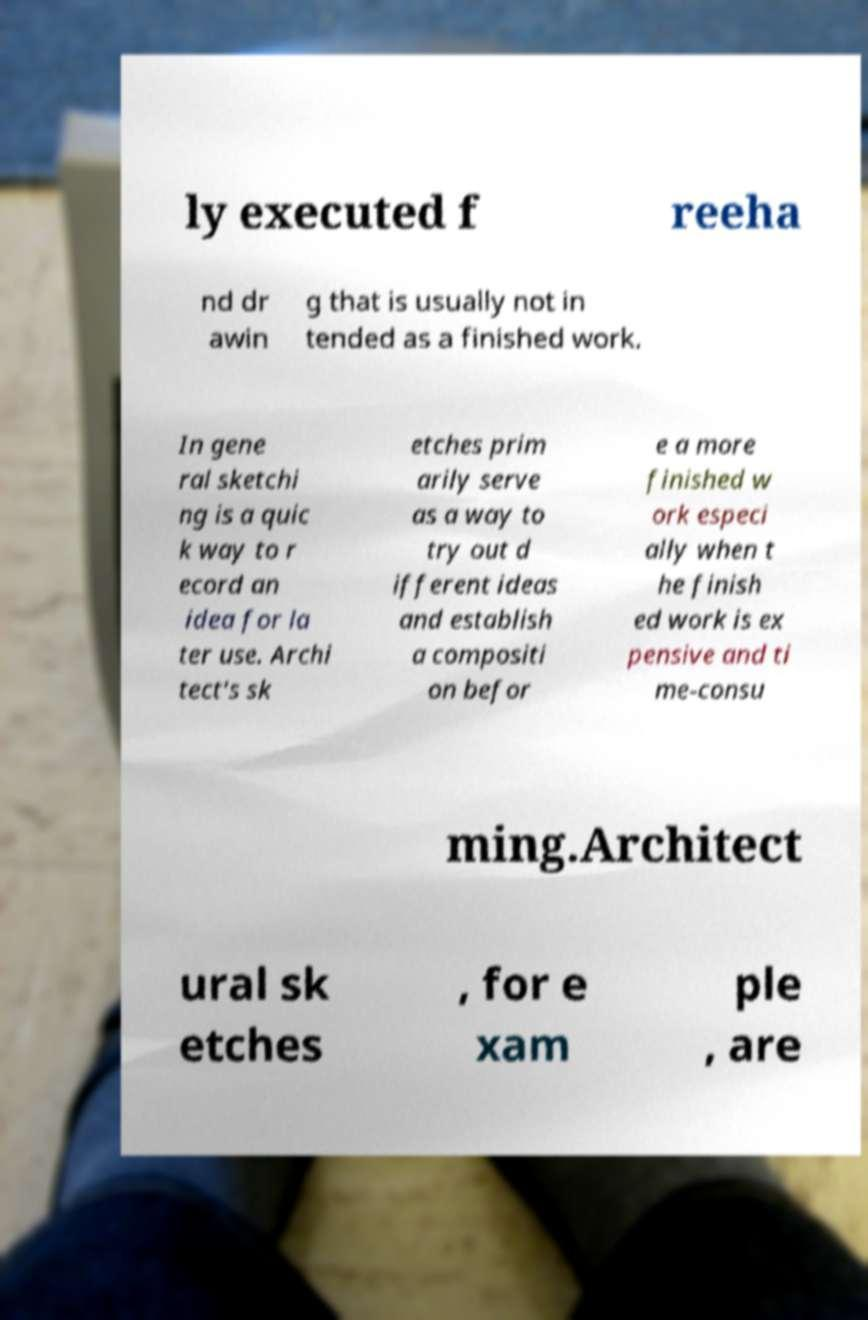There's text embedded in this image that I need extracted. Can you transcribe it verbatim? ly executed f reeha nd dr awin g that is usually not in tended as a finished work. In gene ral sketchi ng is a quic k way to r ecord an idea for la ter use. Archi tect's sk etches prim arily serve as a way to try out d ifferent ideas and establish a compositi on befor e a more finished w ork especi ally when t he finish ed work is ex pensive and ti me-consu ming.Architect ural sk etches , for e xam ple , are 